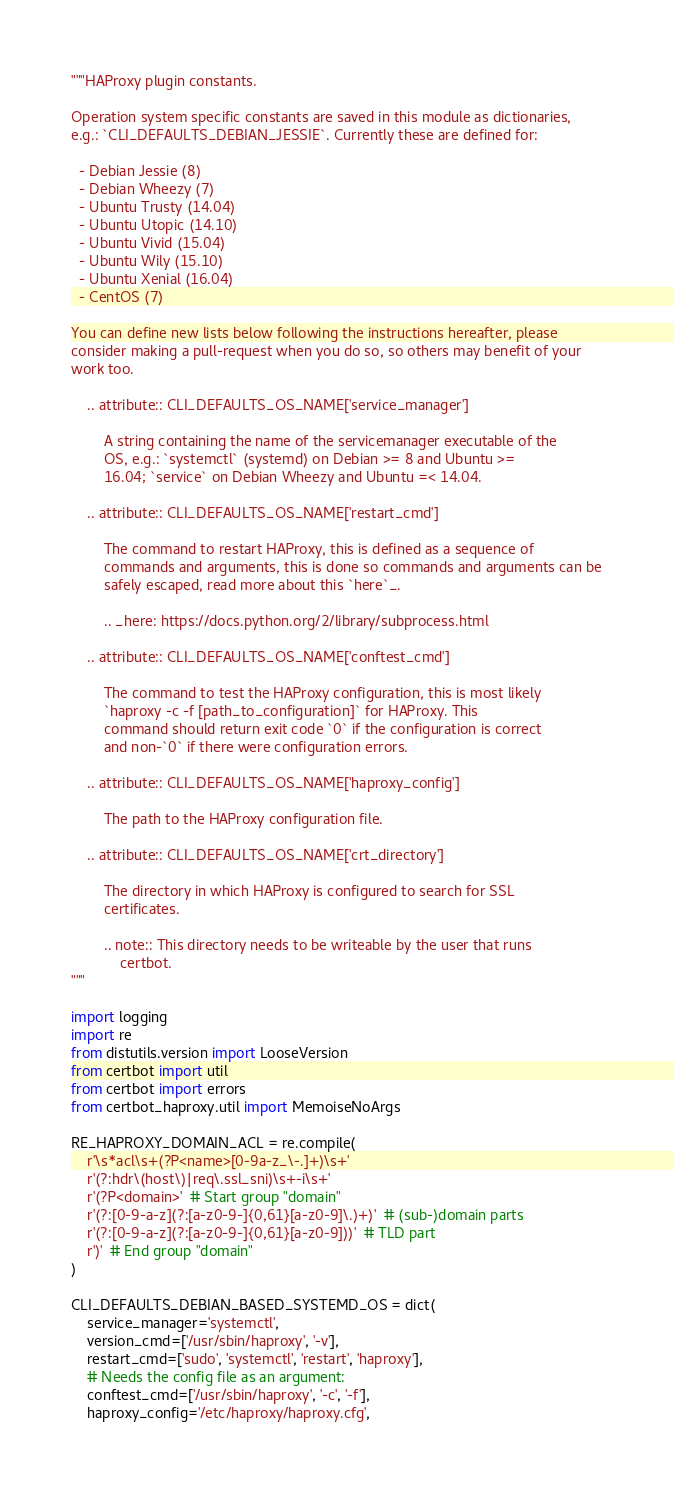Convert code to text. <code><loc_0><loc_0><loc_500><loc_500><_Python_>"""HAProxy plugin constants.

Operation system specific constants are saved in this module as dictionaries,
e.g.: `CLI_DEFAULTS_DEBIAN_JESSIE`. Currently these are defined for:

  - Debian Jessie (8)
  - Debian Wheezy (7)
  - Ubuntu Trusty (14.04)
  - Ubuntu Utopic (14.10)
  - Ubuntu Vivid (15.04)
  - Ubuntu Wily (15.10)
  - Ubuntu Xenial (16.04)
  - CentOS (7)

You can define new lists below following the instructions hereafter, please
consider making a pull-request when you do so, so others may benefit of your
work too.

    .. attribute:: CLI_DEFAULTS_OS_NAME['service_manager']

        A string containing the name of the servicemanager executable of the
        OS, e.g.: `systemctl` (systemd) on Debian >= 8 and Ubuntu >=
        16.04; `service` on Debian Wheezy and Ubuntu =< 14.04.

    .. attribute:: CLI_DEFAULTS_OS_NAME['restart_cmd']

        The command to restart HAProxy, this is defined as a sequence of
        commands and arguments, this is done so commands and arguments can be
        safely escaped, read more about this `here`_.

        .. _here: https://docs.python.org/2/library/subprocess.html

    .. attribute:: CLI_DEFAULTS_OS_NAME['conftest_cmd']

        The command to test the HAProxy configuration, this is most likely
        `haproxy -c -f [path_to_configuration]` for HAProxy. This
        command should return exit code `0` if the configuration is correct
        and non-`0` if there were configuration errors.

    .. attribute:: CLI_DEFAULTS_OS_NAME['haproxy_config']

        The path to the HAProxy configuration file.

    .. attribute:: CLI_DEFAULTS_OS_NAME['crt_directory']

        The directory in which HAProxy is configured to search for SSL
        certificates.

        .. note:: This directory needs to be writeable by the user that runs
            certbot.
"""

import logging
import re
from distutils.version import LooseVersion
from certbot import util
from certbot import errors
from certbot_haproxy.util import MemoiseNoArgs

RE_HAPROXY_DOMAIN_ACL = re.compile(
    r'\s*acl\s+(?P<name>[0-9a-z_\-.]+)\s+'
    r'(?:hdr\(host\)|req\.ssl_sni)\s+-i\s+'
    r'(?P<domain>'  # Start group "domain"
    r'(?:[0-9-a-z](?:[a-z0-9-]{0,61}[a-z0-9]\.)+)'  # (sub-)domain parts
    r'(?:[0-9-a-z](?:[a-z0-9-]{0,61}[a-z0-9]))'  # TLD part
    r')'  # End group "domain"
)

CLI_DEFAULTS_DEBIAN_BASED_SYSTEMD_OS = dict(
    service_manager='systemctl',
    version_cmd=['/usr/sbin/haproxy', '-v'],
    restart_cmd=['sudo', 'systemctl', 'restart', 'haproxy'],
    # Needs the config file as an argument:
    conftest_cmd=['/usr/sbin/haproxy', '-c', '-f'],
    haproxy_config='/etc/haproxy/haproxy.cfg',</code> 